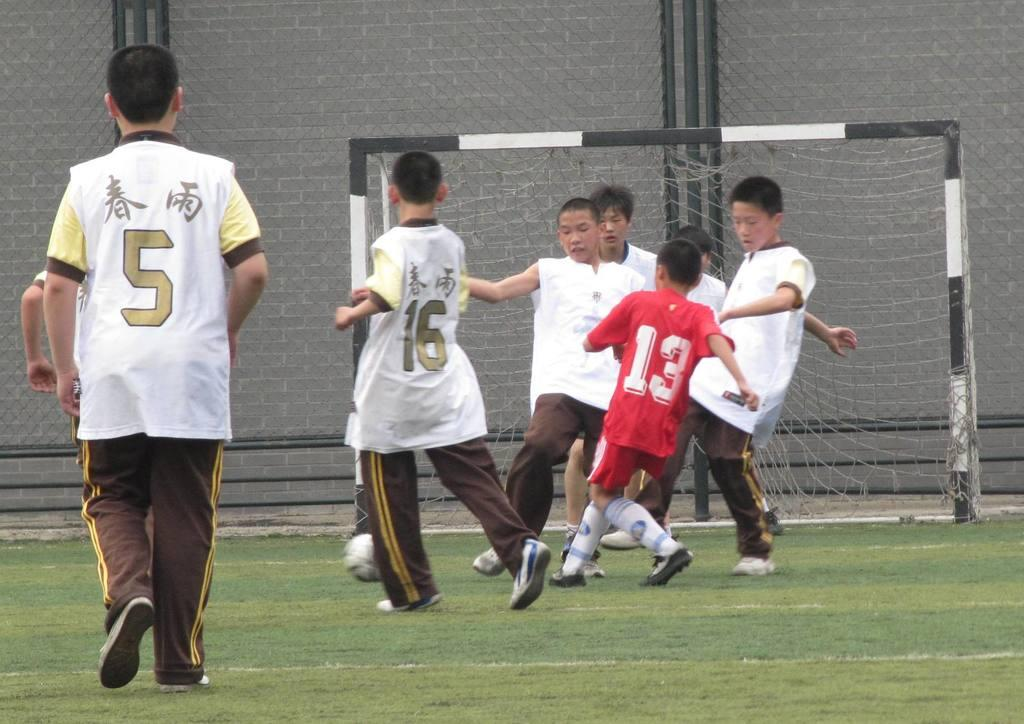<image>
Offer a succinct explanation of the picture presented. A young boy soccer league playing  and some of them have the numbers 5, 16 and, 13. 